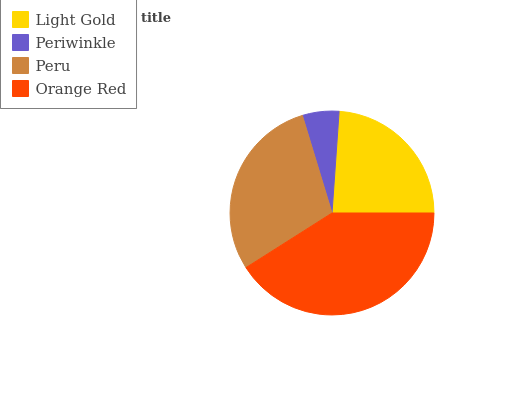Is Periwinkle the minimum?
Answer yes or no. Yes. Is Orange Red the maximum?
Answer yes or no. Yes. Is Peru the minimum?
Answer yes or no. No. Is Peru the maximum?
Answer yes or no. No. Is Peru greater than Periwinkle?
Answer yes or no. Yes. Is Periwinkle less than Peru?
Answer yes or no. Yes. Is Periwinkle greater than Peru?
Answer yes or no. No. Is Peru less than Periwinkle?
Answer yes or no. No. Is Peru the high median?
Answer yes or no. Yes. Is Light Gold the low median?
Answer yes or no. Yes. Is Orange Red the high median?
Answer yes or no. No. Is Orange Red the low median?
Answer yes or no. No. 